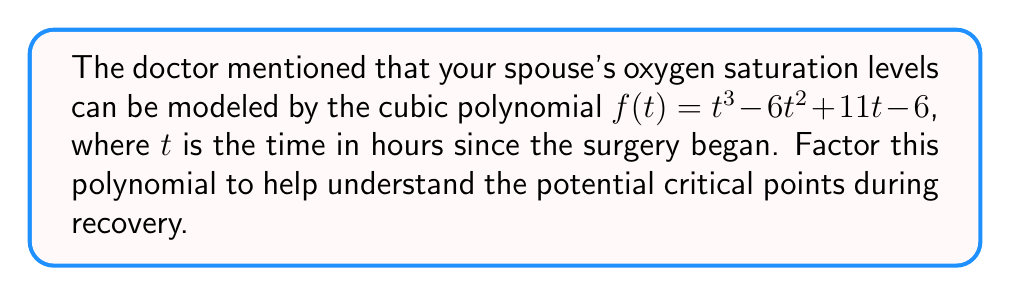Give your solution to this math problem. Let's factor this cubic polynomial step-by-step:

1) First, we'll try to find a factor by guessing rational roots. The possible rational roots are the factors of the constant term: ±1, ±2, ±3, ±6.

2) Let's start with 1:
   $f(1) = 1^3 - 6(1^2) + 11(1) - 6 = 1 - 6 + 11 - 6 = 0$

3) Since $f(1) = 0$, $(t-1)$ is a factor of $f(t)$.

4) We can use polynomial long division to find the other factor:

   $$\frac{t^3 - 6t^2 + 11t - 6}{t - 1} = t^2 - 5t + 6$$

5) So, $f(t) = (t-1)(t^2 - 5t + 6)$

6) Now we need to factor the quadratic term $t^2 - 5t + 6$:
   - The sum of its roots is 5
   - The product of its roots is 6
   - The factors of 6 that add up to 5 are 2 and 3

7) Therefore, $t^2 - 5t + 6 = (t-2)(t-3)$

8) Putting it all together:
   $f(t) = (t-1)(t-2)(t-3)$

This factorization shows that the oxygen saturation levels will be zero (critical points) at $t=1$, $t=2$, and $t=3$ hours after the surgery began.
Answer: $(t-1)(t-2)(t-3)$ 